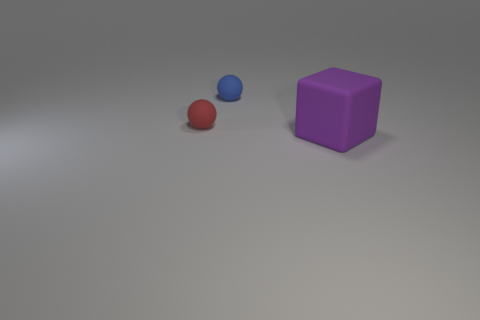How many objects are either large purple cubes or matte things to the right of the blue thing?
Offer a terse response. 1. There is a object that is in front of the blue thing and behind the big purple block; what is its material?
Provide a short and direct response. Rubber. Is there anything else that has the same shape as the big object?
Your response must be concise. No. There is another big thing that is made of the same material as the red object; what color is it?
Give a very brief answer. Purple. What number of things are small blue rubber things or big gray metal balls?
Provide a short and direct response. 1. There is a blue rubber thing; is its size the same as the matte object in front of the tiny red matte object?
Make the answer very short. No. What is the color of the thing that is in front of the rubber sphere that is on the left side of the rubber thing behind the red rubber sphere?
Keep it short and to the point. Purple. The big rubber thing is what color?
Provide a short and direct response. Purple. Is the number of tiny blue objects that are in front of the big purple rubber block greater than the number of large purple objects behind the red thing?
Your answer should be compact. No. Does the large matte object have the same shape as the rubber thing on the left side of the blue matte ball?
Offer a very short reply. No. 